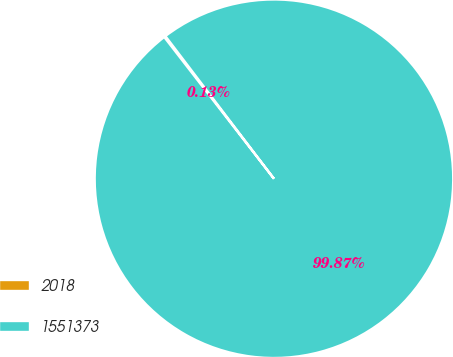<chart> <loc_0><loc_0><loc_500><loc_500><pie_chart><fcel>2018<fcel>1551373<nl><fcel>0.13%<fcel>99.87%<nl></chart> 